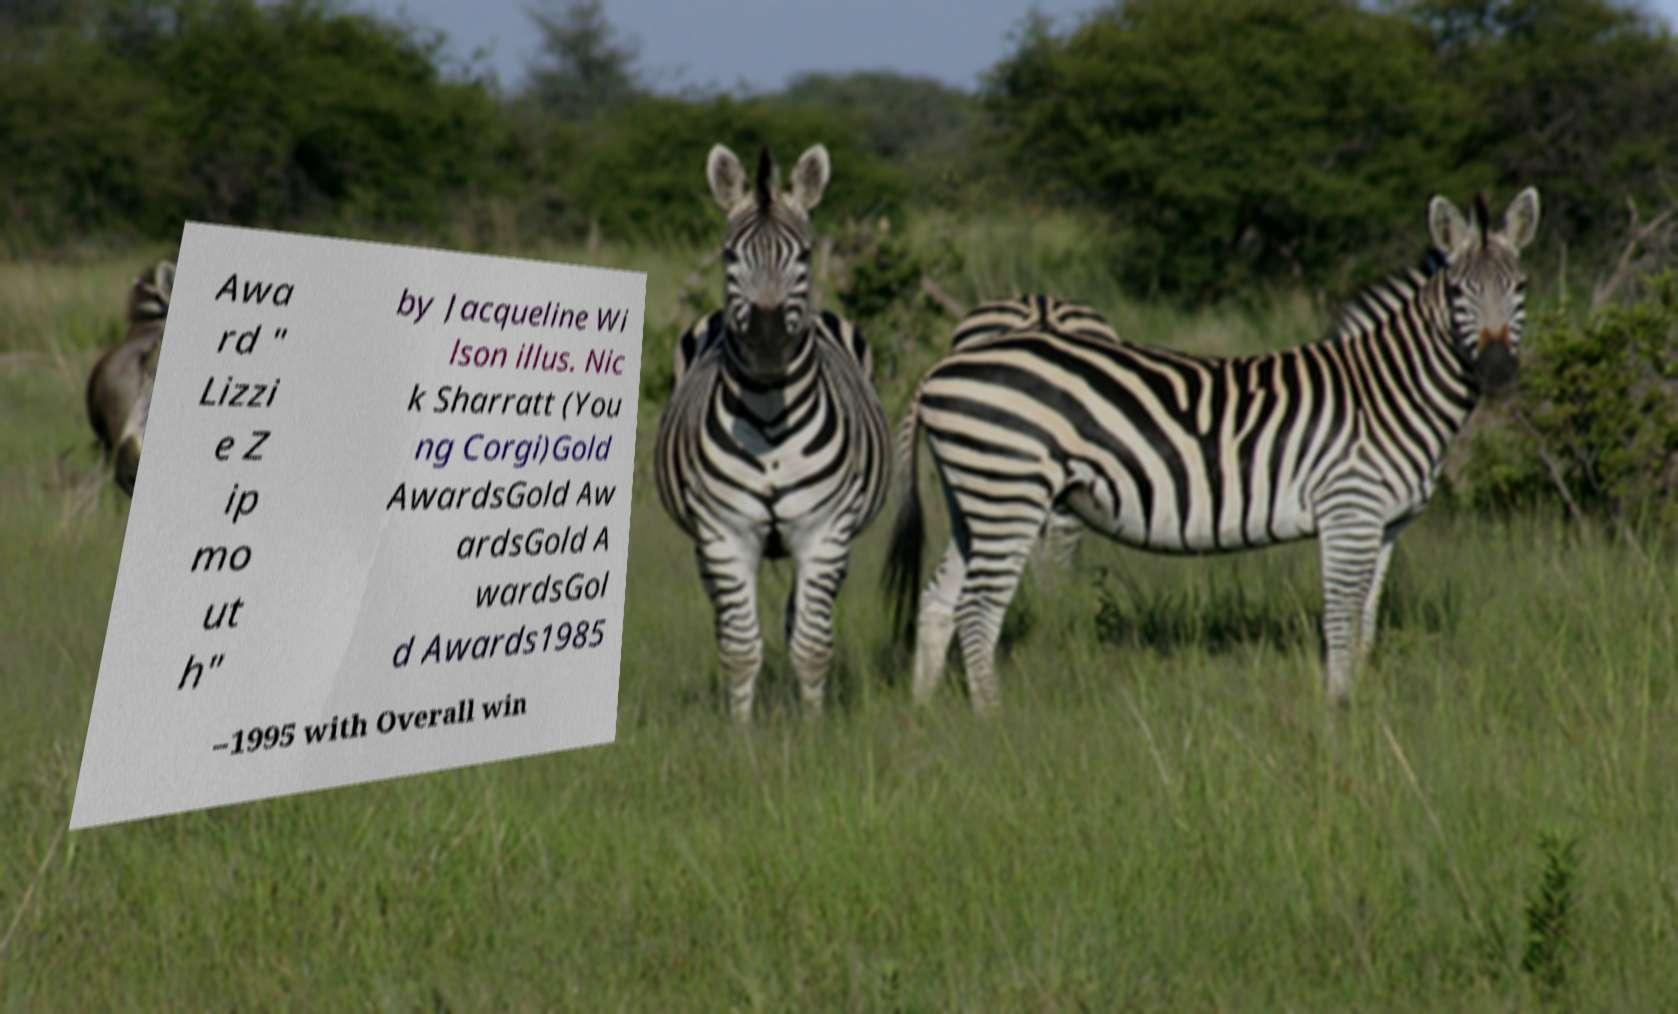Could you assist in decoding the text presented in this image and type it out clearly? Awa rd " Lizzi e Z ip mo ut h" by Jacqueline Wi lson illus. Nic k Sharratt (You ng Corgi)Gold AwardsGold Aw ardsGold A wardsGol d Awards1985 –1995 with Overall win 